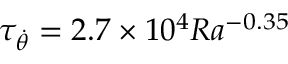<formula> <loc_0><loc_0><loc_500><loc_500>\tau _ { \dot { \theta } } = 2 . 7 \times 1 0 ^ { 4 } R a ^ { - 0 . 3 5 }</formula> 